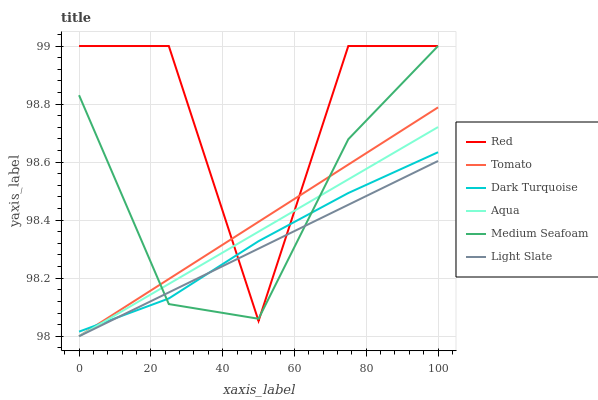Does Light Slate have the minimum area under the curve?
Answer yes or no. Yes. Does Red have the maximum area under the curve?
Answer yes or no. Yes. Does Dark Turquoise have the minimum area under the curve?
Answer yes or no. No. Does Dark Turquoise have the maximum area under the curve?
Answer yes or no. No. Is Light Slate the smoothest?
Answer yes or no. Yes. Is Red the roughest?
Answer yes or no. Yes. Is Dark Turquoise the smoothest?
Answer yes or no. No. Is Dark Turquoise the roughest?
Answer yes or no. No. Does Tomato have the lowest value?
Answer yes or no. Yes. Does Dark Turquoise have the lowest value?
Answer yes or no. No. Does Red have the highest value?
Answer yes or no. Yes. Does Dark Turquoise have the highest value?
Answer yes or no. No. Does Red intersect Aqua?
Answer yes or no. Yes. Is Red less than Aqua?
Answer yes or no. No. Is Red greater than Aqua?
Answer yes or no. No. 